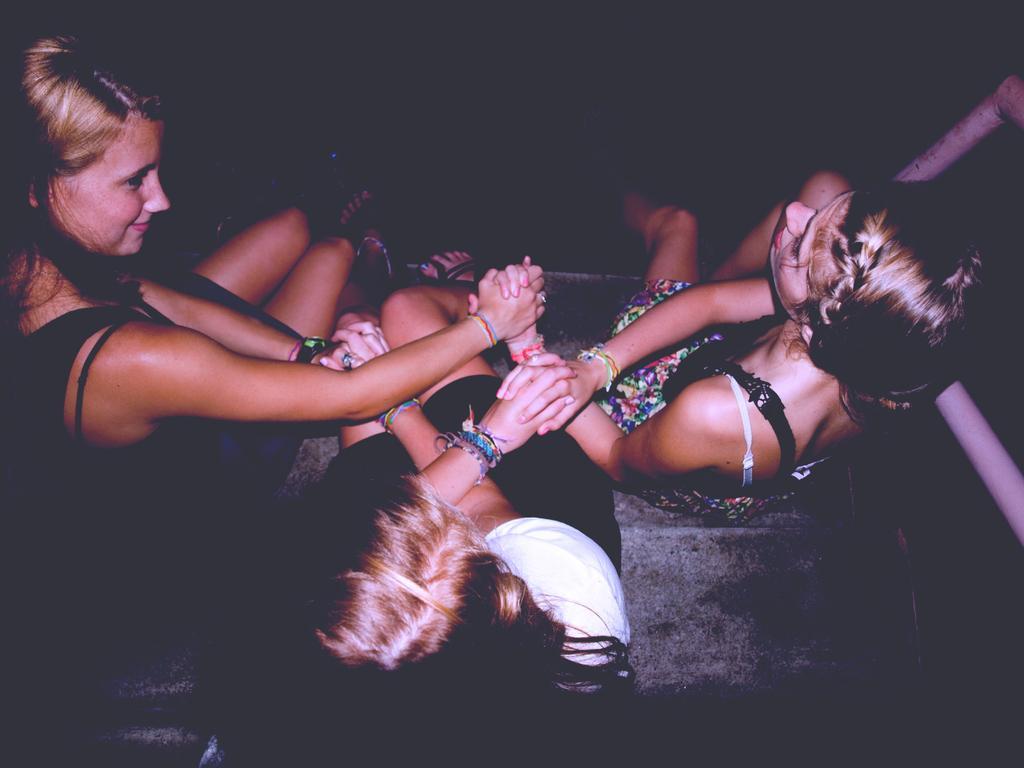How would you summarize this image in a sentence or two? In this image, we can see three women are sitting. each other they are holding hands. Left side of the image, we can see a woman is smiling. Right side of the image, we can see few rods. 